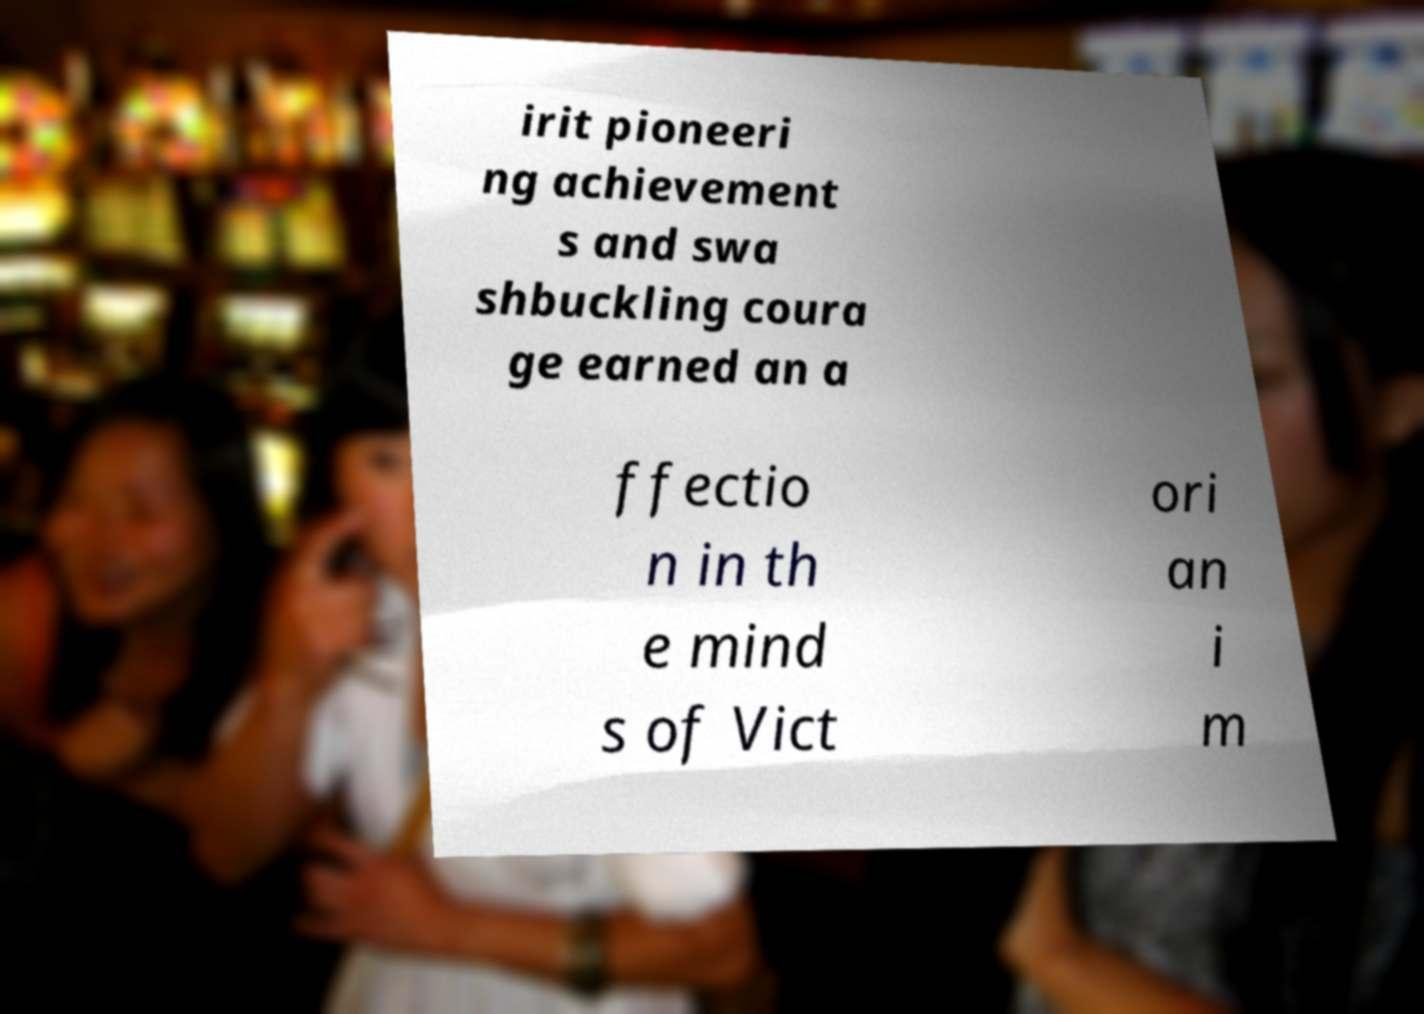Please identify and transcribe the text found in this image. irit pioneeri ng achievement s and swa shbuckling coura ge earned an a ffectio n in th e mind s of Vict ori an i m 